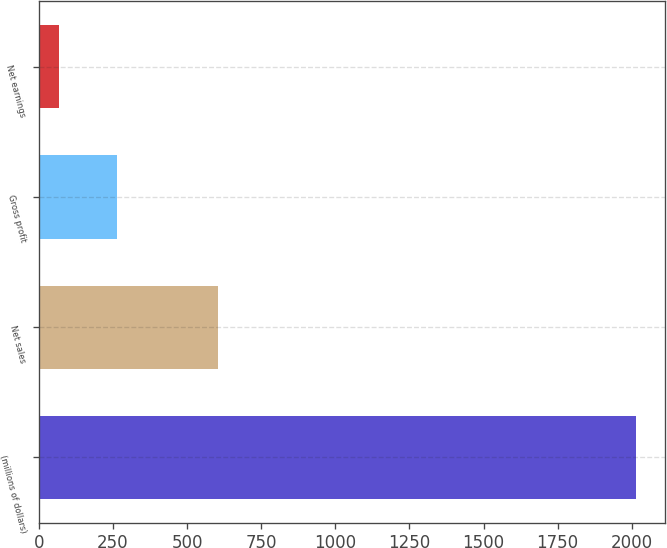Convert chart. <chart><loc_0><loc_0><loc_500><loc_500><bar_chart><fcel>(millions of dollars)<fcel>Net sales<fcel>Gross profit<fcel>Net earnings<nl><fcel>2013<fcel>604<fcel>262.77<fcel>68.3<nl></chart> 